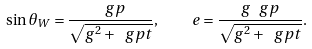<formula> <loc_0><loc_0><loc_500><loc_500>\sin \theta _ { W } = \frac { \ g p } { \sqrt { g ^ { 2 } + \ g p t } } , \quad e = \frac { g \ g p } { \sqrt { g ^ { 2 } + \ g p t } } .</formula> 